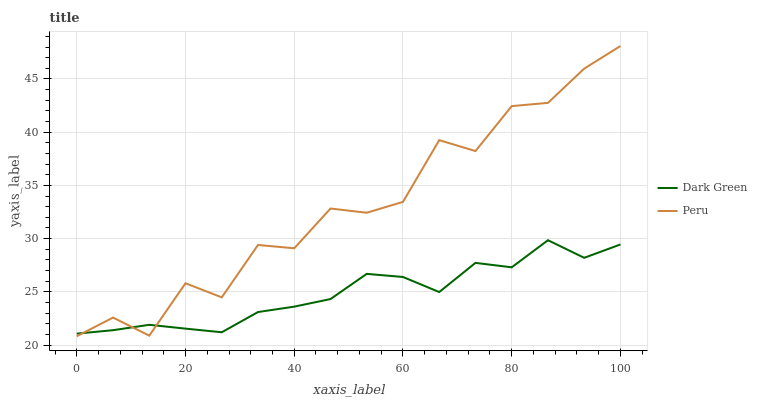Does Dark Green have the minimum area under the curve?
Answer yes or no. Yes. Does Peru have the maximum area under the curve?
Answer yes or no. Yes. Does Dark Green have the maximum area under the curve?
Answer yes or no. No. Is Dark Green the smoothest?
Answer yes or no. Yes. Is Peru the roughest?
Answer yes or no. Yes. Is Dark Green the roughest?
Answer yes or no. No. Does Dark Green have the lowest value?
Answer yes or no. No. Does Peru have the highest value?
Answer yes or no. Yes. Does Dark Green have the highest value?
Answer yes or no. No. 